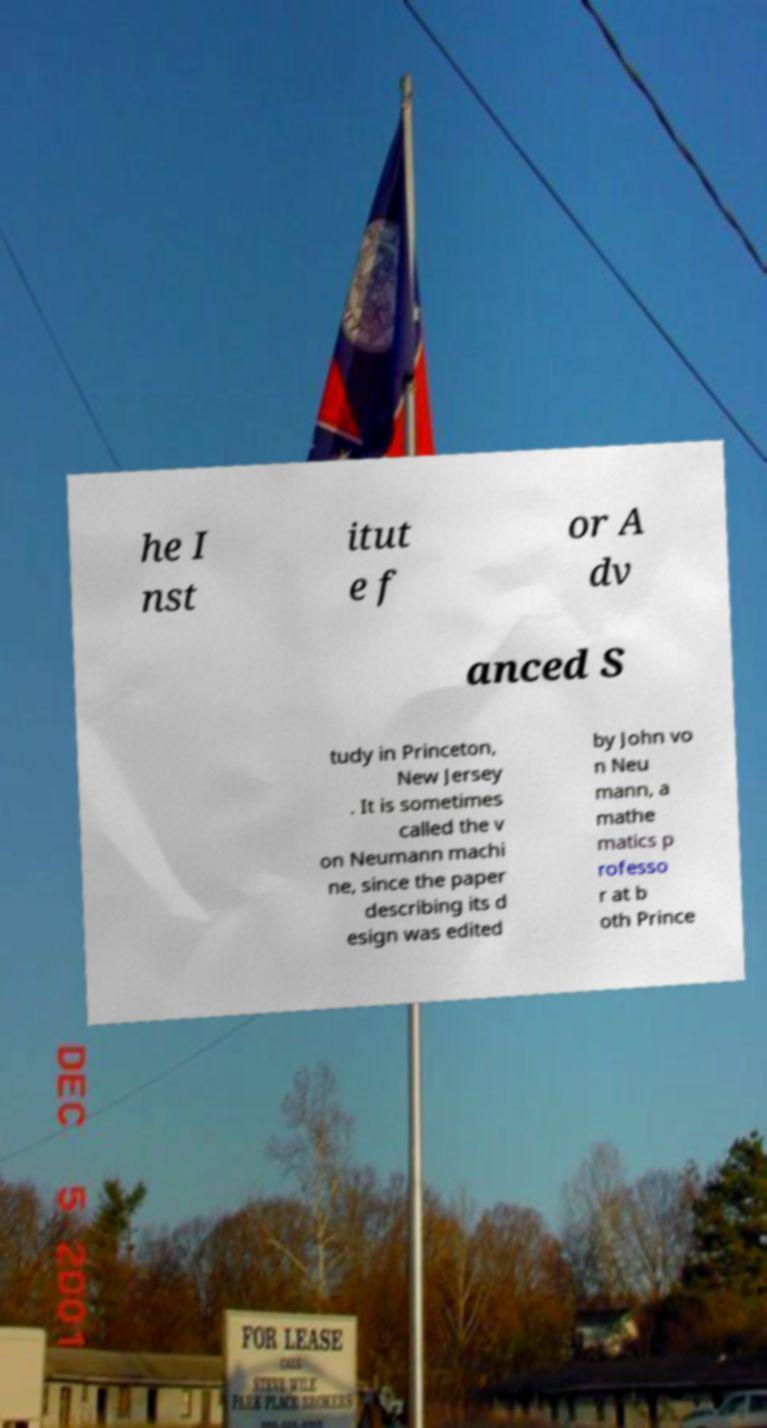Could you assist in decoding the text presented in this image and type it out clearly? he I nst itut e f or A dv anced S tudy in Princeton, New Jersey . It is sometimes called the v on Neumann machi ne, since the paper describing its d esign was edited by John vo n Neu mann, a mathe matics p rofesso r at b oth Prince 